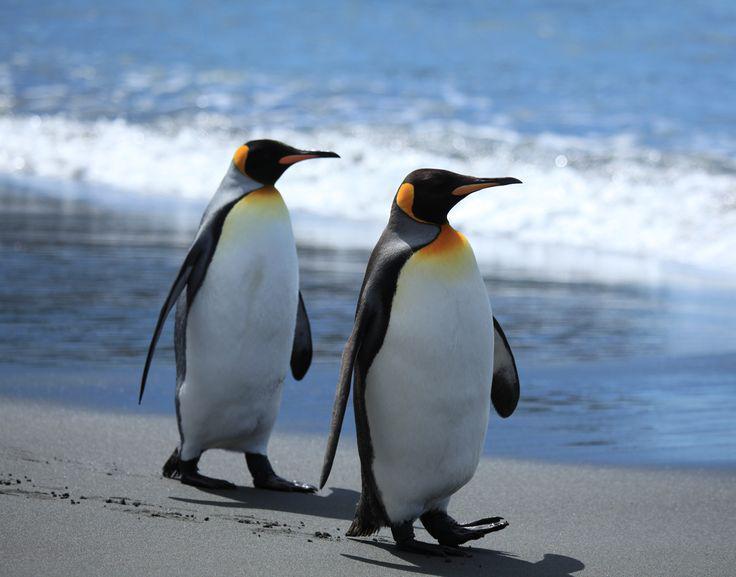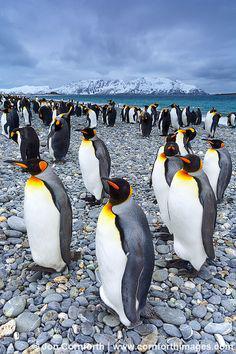The first image is the image on the left, the second image is the image on the right. Assess this claim about the two images: "Penguins in the left image are walking on ice.". Correct or not? Answer yes or no. No. The first image is the image on the left, the second image is the image on the right. For the images displayed, is the sentence "In at least one of the imagines there is a view of the beach with no more than 3 penguins walking together." factually correct? Answer yes or no. Yes. 